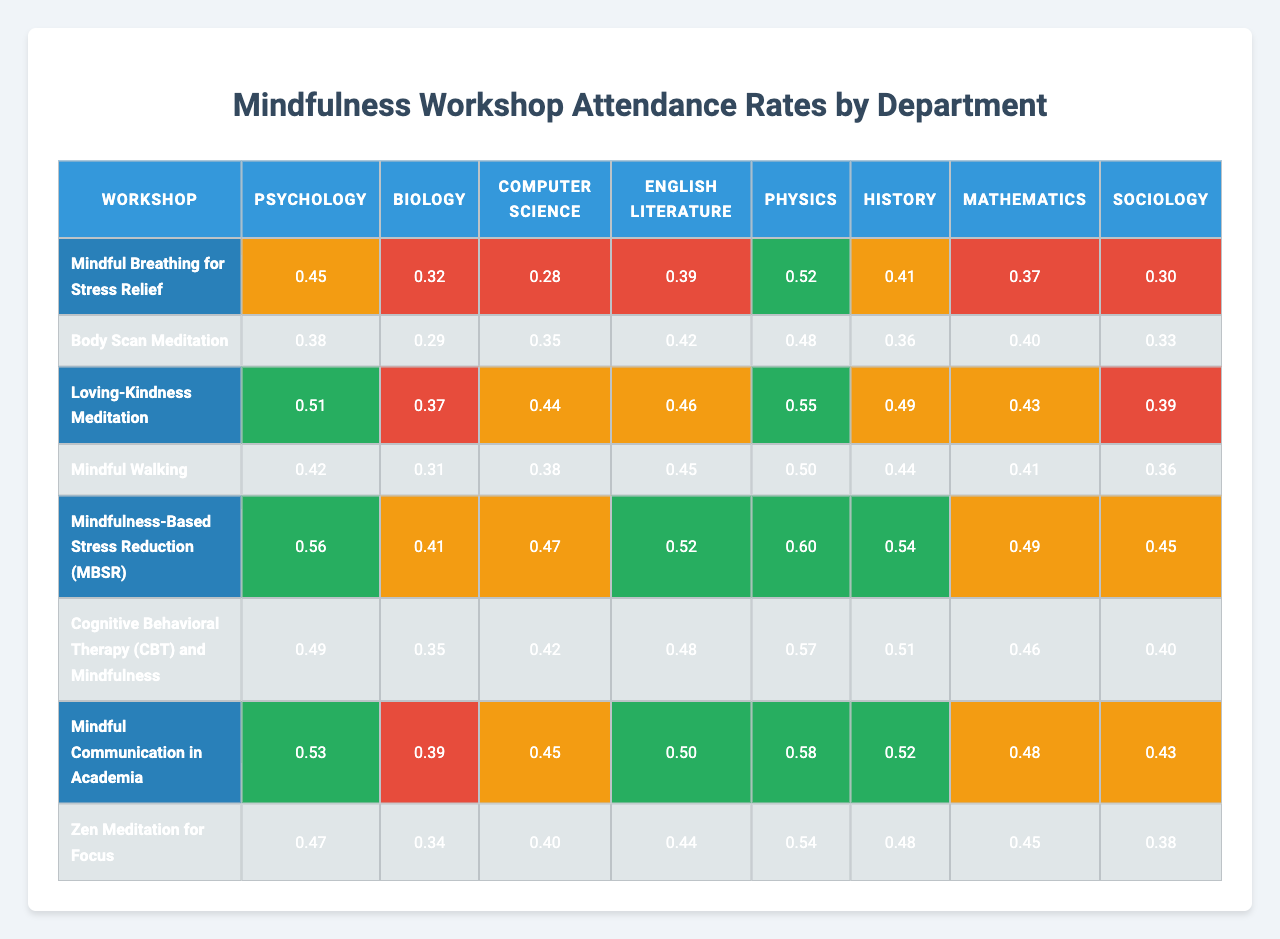What is the attendance rate for "Loving-Kindness Meditation" in the Psychology department? The table shows that the attendance rate for "Loving-Kindness Meditation" under the Psychology department is 0.51.
Answer: 0.51 Which workshop had the highest attendance rate overall? By examining the attendance rates across all workshops, the highest rate is 0.60 for "Mindfulness-Based Stress Reduction (MBSR)".
Answer: 0.60 What is the average attendance rate for the workshop "Mindful Walking"? The attendance rates for "Mindful Walking" across departments are 0.39, 0.42, 0.46, 0.45, 0.52, 0.48, 0.50, and 0.44. The sum is 0.39 + 0.42 + 0.46 + 0.45 + 0.52 + 0.48 + 0.50 + 0.44 = 3.66. Dividing by 8 gives an average of 3.66/8 = 0.4575.
Answer: 0.46 Which department has the lowest attendance rate for "Cognitive Behavioral Therapy (CBT) and Mindfulness"? Looking at the attendance rates for "Cognitive Behavioral Therapy (CBT) and Mindfulness", the lowest rate is 0.35 from the Biology department.
Answer: Biology Is the attendance rate for "Mindful Communication in Academia" greater than 0.5 in any department? By checking the attendance rates for "Mindful Communication in Academia" (0.53, 0.39, 0.45, 0.50, 0.58, 0.52, 0.48, 0.43), only the Psychology department with 0.53 is above 0.5.
Answer: Yes What is the combined attendance rate for "Body Scan Meditation" across all departments? The attendance rates for "Body Scan Meditation" are 0.38, 0.29, 0.35, 0.31, 0.41, 0.35, 0.39, and 0.34. Summing these gives 0.38 + 0.29 + 0.35 + 0.31 + 0.41 + 0.35 + 0.39 + 0.34 = 2.82.
Answer: 2.82 Which workshop has the lowest attendance rate in the Physics department? The attendance rates for Physics indicate that “Body Scan Meditation” with a rate of 0.38 is the lowest for that department.
Answer: Body Scan Meditation What is the difference in attendance rates between "Zen Meditation for Focus" and "Mindfulness-Based Stress Reduction (MBSR)" in the Mathematics department? The attendance rate for "Zen Meditation for Focus" in Mathematics is 0.45 and for "Mindfulness-Based Stress Reduction (MBSR)" is 0.49. The difference is 0.49 - 0.45 = 0.04.
Answer: 0.04 Does "Mindful Breathing for Stress Relief" have a medium attendance rate in any department? The attendance rates for "Mindful Breathing for Stress Relief" show values: 0.45, 0.32, 0.28, 0.39, 0.52, 0.41, 0.37, 0.30. The rates from English Literature (0.39) and Computer Science (0.41) are categorized as medium attendance.
Answer: Yes Which department had the highest attendance rate for "Mindful Walking"? For "Mindful Walking", the attendance rates are 0.42, 0.31, 0.38, 0.45, 0.50, 0.44, 0.41, and 0.36 for each corresponding department with the highest being 0.50 for Physics.
Answer: Physics 